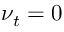Convert formula to latex. <formula><loc_0><loc_0><loc_500><loc_500>\nu _ { t } = 0</formula> 